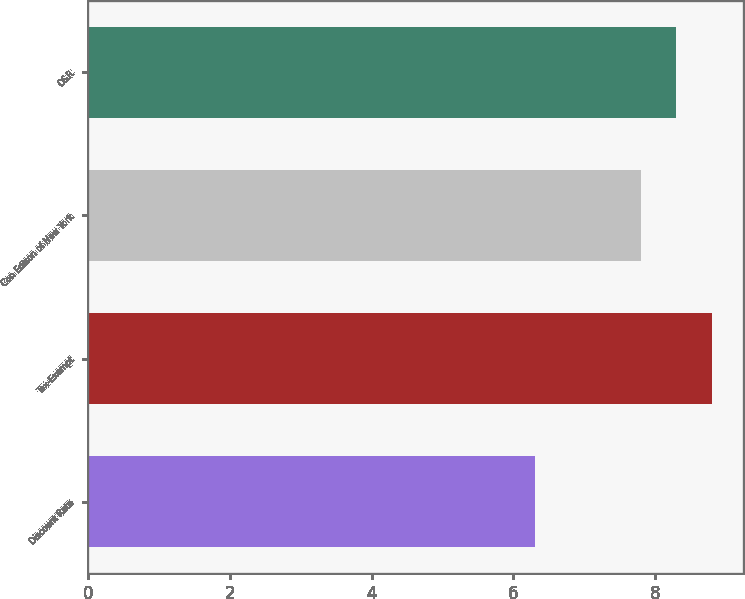Convert chart. <chart><loc_0><loc_0><loc_500><loc_500><bar_chart><fcel>Discount Rate<fcel>Tax-Exempt<fcel>Con Edison of New York<fcel>O&R<nl><fcel>6.3<fcel>8.8<fcel>7.8<fcel>8.3<nl></chart> 